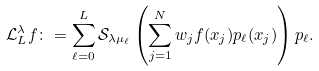<formula> <loc_0><loc_0><loc_500><loc_500>\mathcal { L } _ { L } ^ { \lambda } f \colon = \sum _ { \ell = 0 } ^ { L } \mathcal { S } _ { \lambda \mu _ { \ell } } \left ( \sum _ { j = 1 } ^ { N } w _ { j } f ( x _ { j } ) p _ { \ell } ( x _ { j } ) \right ) p _ { \ell } .</formula> 